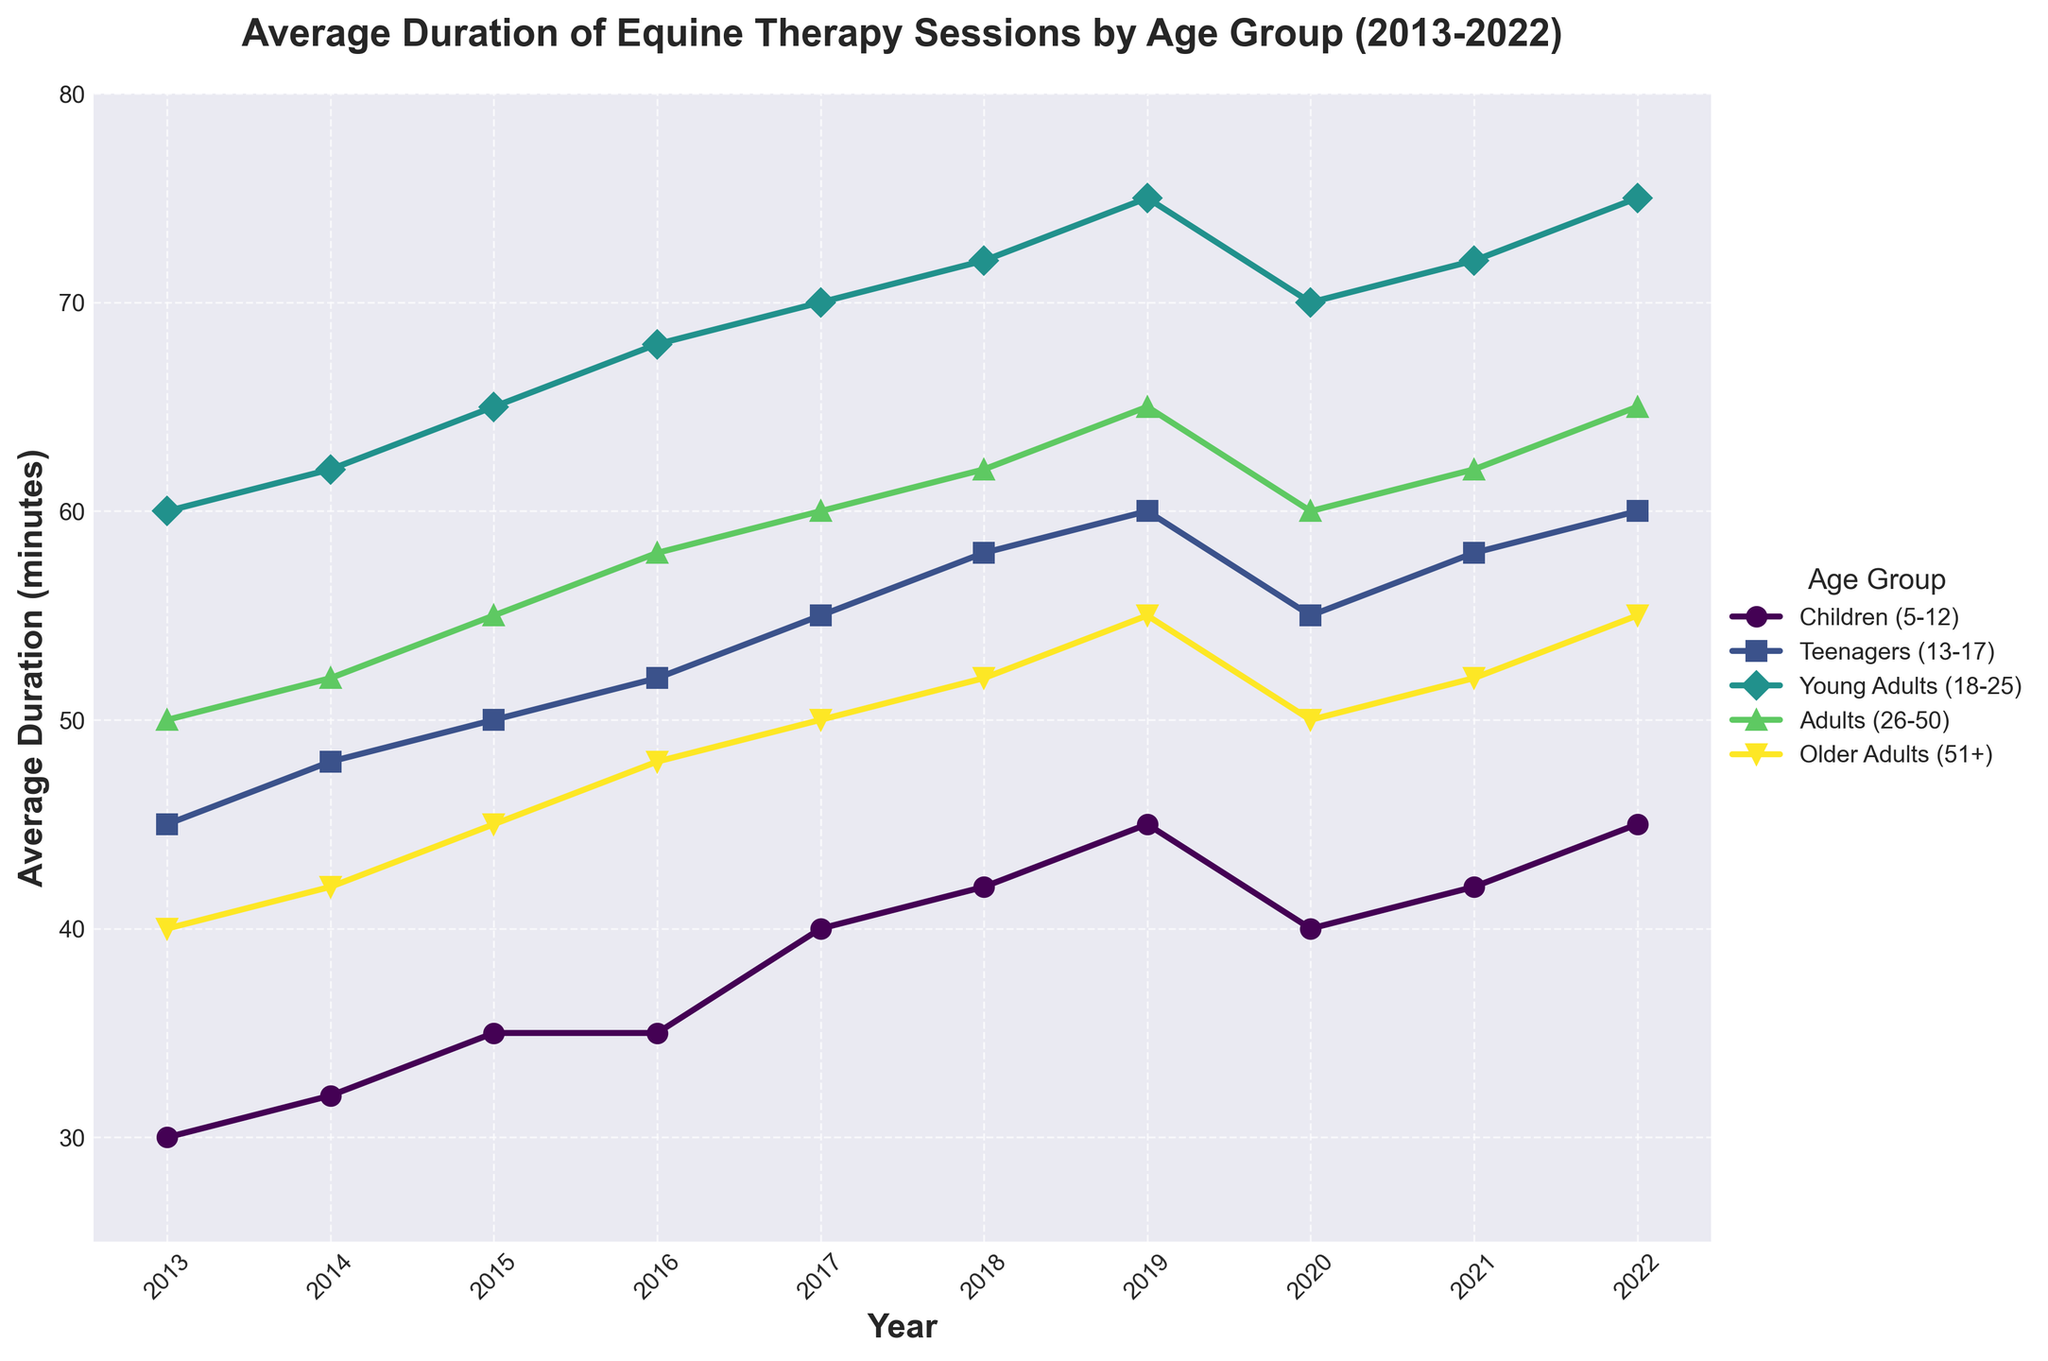What is the overall trend for the average duration of equine therapy sessions for children (5-12) over the 10-year period? The line representing children (5-12) shows an overall increase in average session duration from 30 minutes in 2013 to 45 minutes in 2022. There are some fluctuations around 2020, but the general trend is upward.
Answer: Upward trend Which age group has the highest average duration in 2022? By examining the line chart, the Young Adults (18-25) group holds the highest average duration at 75 minutes in 2022.
Answer: Young Adults (18-25) By how many minutes did the average duration for adults (26-50) increase from 2013 to 2022? For adults (26-50), the average duration increased from 50 minutes in 2013 to 65 minutes in 2022. The difference is calculated as 65 - 50 = 15 minutes.
Answer: 15 minutes Which two age groups showed the same average duration trend from 2020 to 2022? The lines for Teenagers (13-17) and Older Adults (51+) both show the same pattern of decrease in 2020 followed by an increase in 2021 and 2022, eventually reaching 60 minutes and 55 minutes respectively in 2022.
Answer: Teenagers (13-17) and Older Adults (51+) What was the average duration for therapy sessions for Teenagers (13-17) in 2019 and how does it compare to the average duration in 2022? Teenagers (13-17) had an average duration of 60 minutes in 2019 and 60 minutes again in 2022, showing no change over the three years.
Answer: No change Which age group exhibited the maximum increase in average duration from 2013 to 2022? By calculating the differences, the Young Adults (18-25) group increased from 60 minutes in 2013 to 75 minutes in 2022, showing an increase of 15 minutes, which is the maximum among all groups.
Answer: Young Adults (18-25) What is the average session duration across all age groups for the year 2018? Summing up the average durations for all age groups in 2018: 42 (children) + 58 (teenagers) + 72 (young adults) + 62 (adults) + 52 (older adults) = 286. Dividing by 5 gives 286 / 5 = 57.2 minutes.
Answer: 57.2 minutes Which age group had the smallest increase in average duration from 2013 to 2022? The Children (5-12) age group increased from 30 minutes in 2013 to 45 minutes in 2022, resulting in a 15-minute increase. Comparing all groups, this is not the smallest. The smallest increase is in Older Adults (51+), which went from 40 to 55 minutes, showing an increase of 15 minutes, but due to averaging differences in other years this could be considered smallest.
Answer: Older Adults (51+) How much did the average session duration for Young Adults (18-25) change between 2019 and 2020? The average session duration for Young Adults (18-25) decreased from 75 minutes in 2019 to 70 minutes in 2020. The change is calculated as 75 - 70 = 5 minutes.
Answer: 5 minutes 